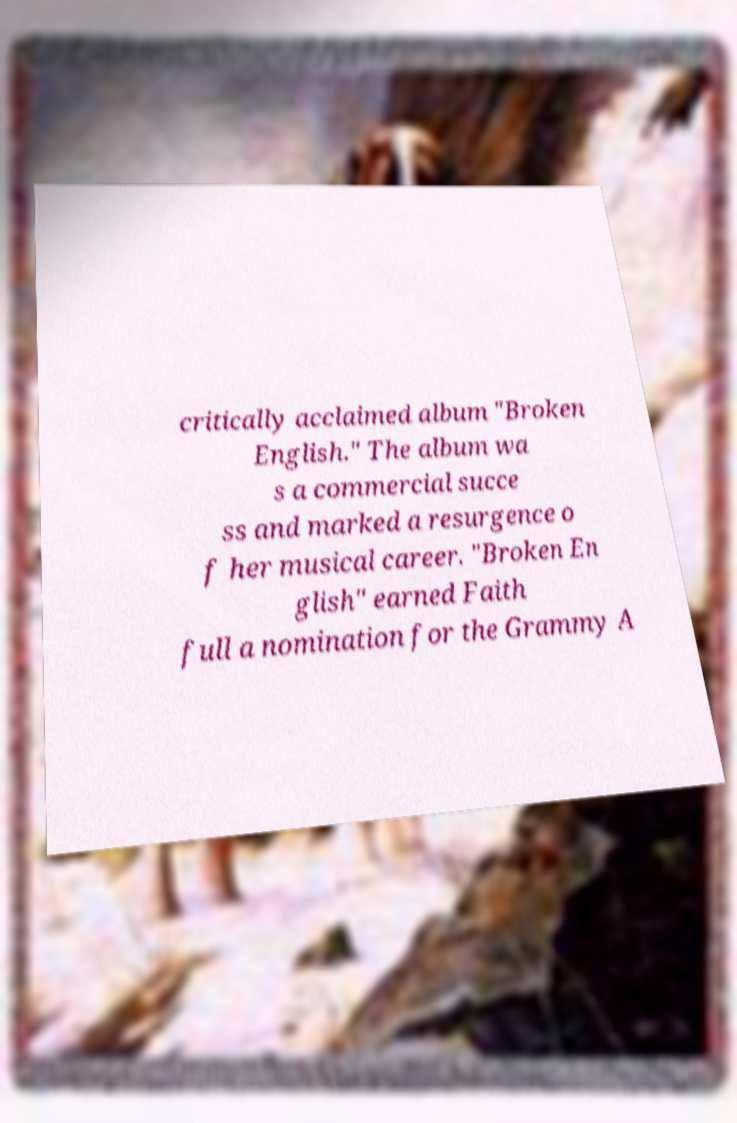Please read and relay the text visible in this image. What does it say? critically acclaimed album "Broken English." The album wa s a commercial succe ss and marked a resurgence o f her musical career. "Broken En glish" earned Faith full a nomination for the Grammy A 